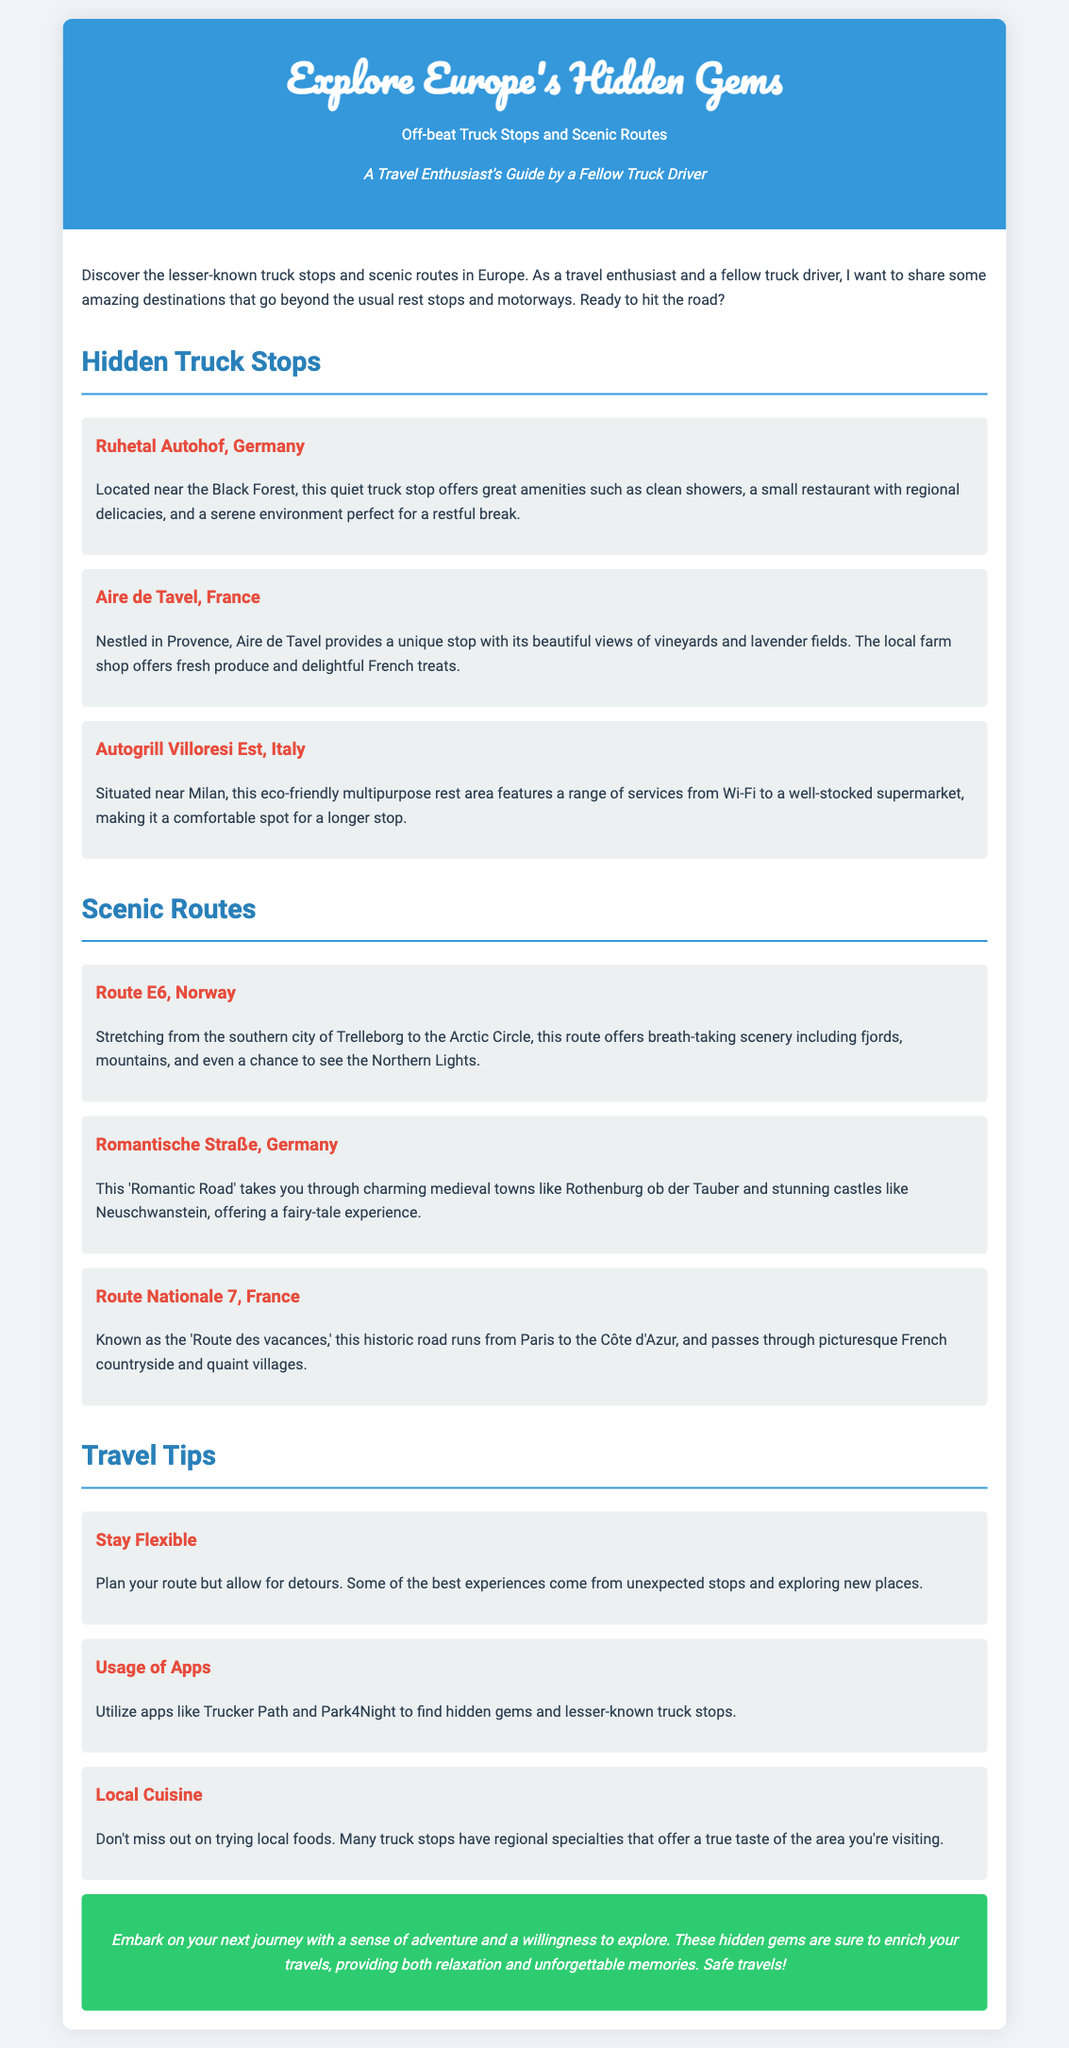What is the title of the flyer? The title of the flyer is prominently displayed at the top of the document.
Answer: Explore Europe's Hidden Gems: Off-beat Truck Stops and Scenic Routes How many hidden truck stops are listed in the document? The document provides three examples of hidden truck stops in the provided section.
Answer: 3 What type of food can you find at Aire de Tavel? The document mentions that the local farm shop offers specific goods.
Answer: Fresh produce and delightful French treats Which scenic route is known for passing through fjords and mountains? The document specifically mentions this scenic route under Norway.
Answer: Route E6 What travel tip suggests using specific apps? The document includes a travel tip that encourages the use of technology to find destinations.
Answer: Usage of Apps What is the main theme of this document? The content of the document revolves around specific destinations and tips for truck drivers.
Answer: Hidden gems for truck drivers Which country is Ruhetal Autohof located in? The document specifies the country where this hidden truck stop is situated.
Answer: Germany What color is the background of the document? The document's background color is described in the style section.
Answer: Light gray (or #f0f4f8) 